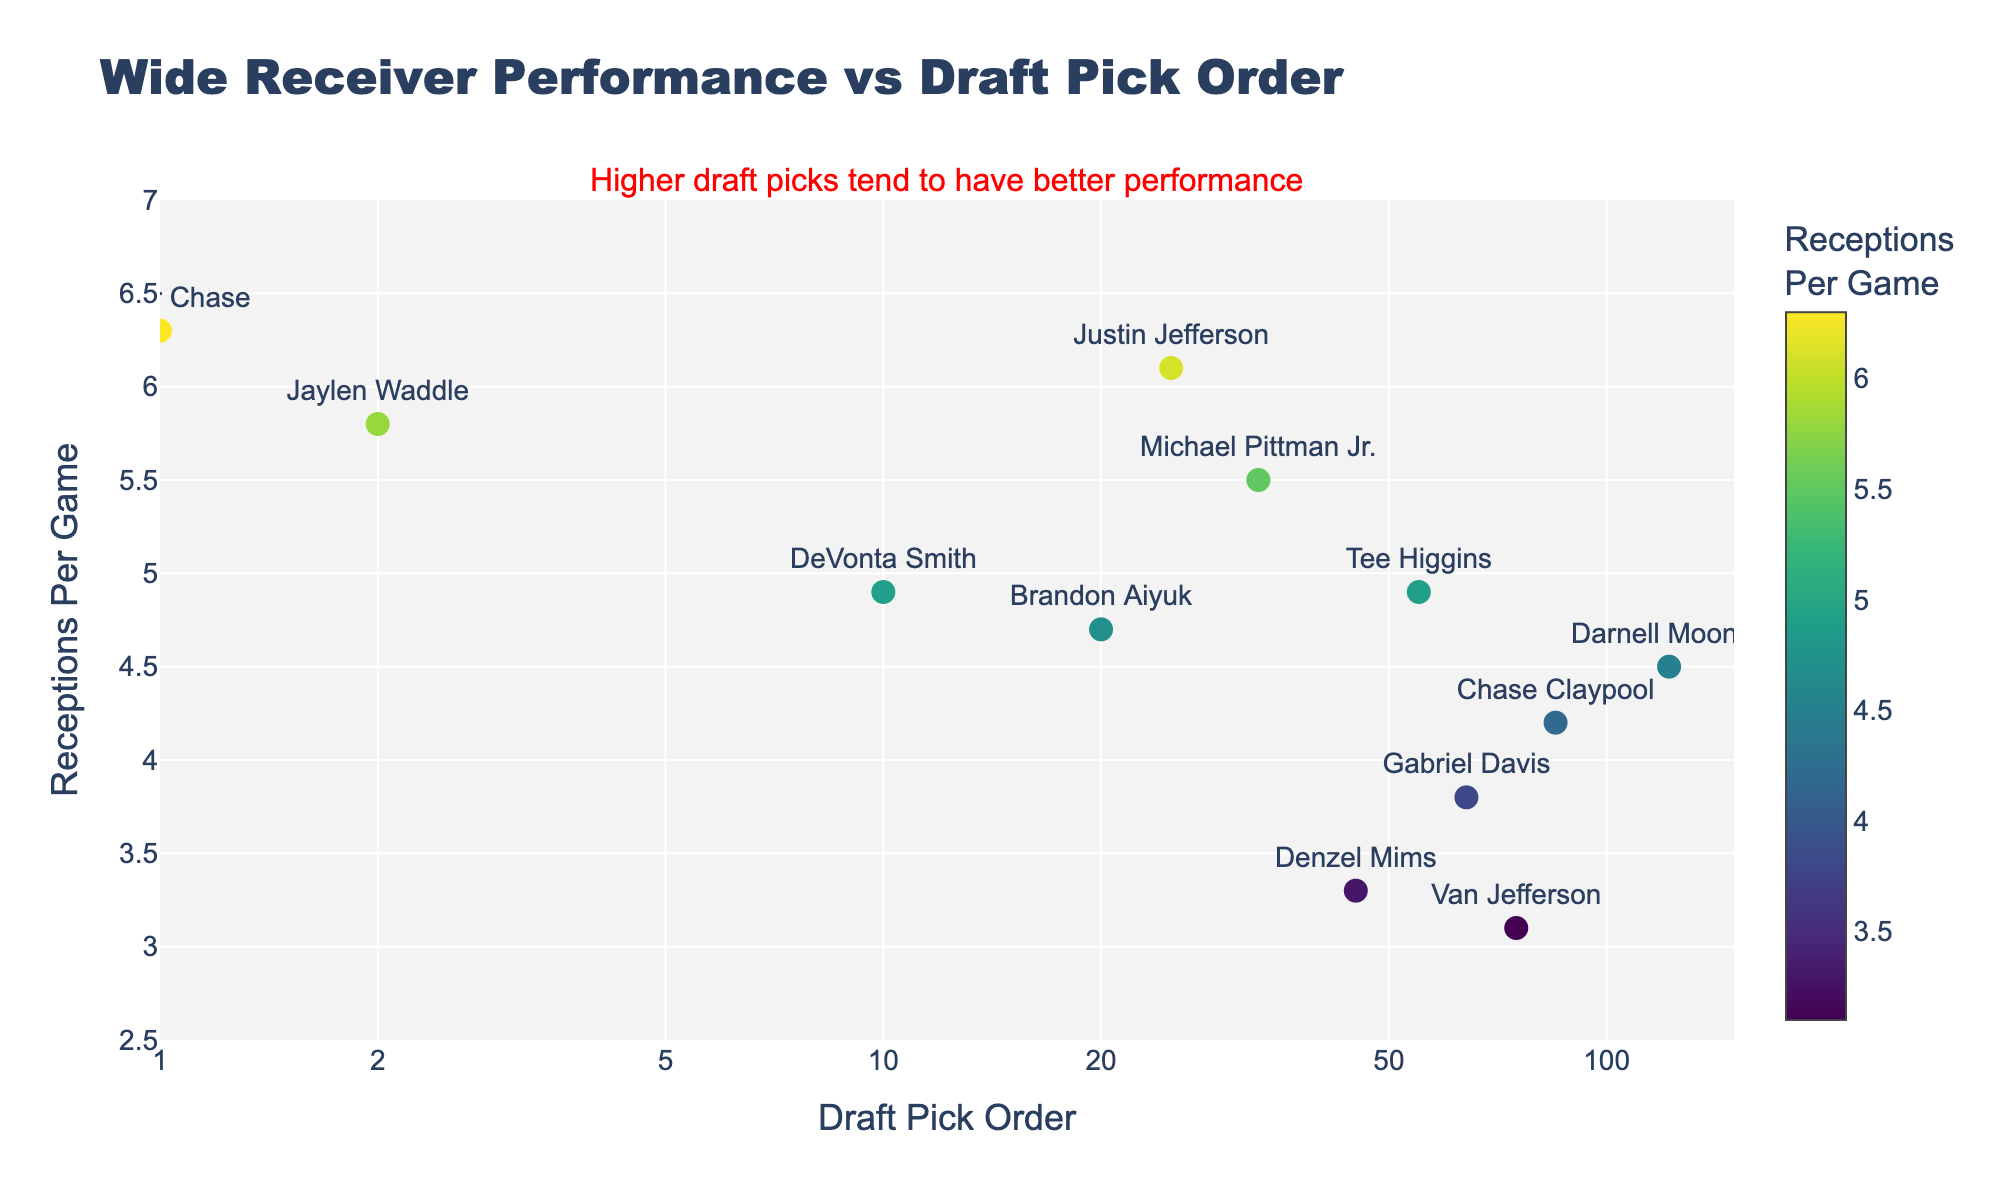What is the title of the figure? The title of the figure is prominently displayed at the top of the chart.
Answer: Wide Receiver Performance vs Draft Pick Order How many players are represented in the plot? Each marker corresponds to a player, and by counting the markers, we can determine the number of players.
Answer: 12 What color scale is used for the markers? The color scale is indicated by the colorbar to the right of the plot, which shows a gradual transition in colors.
Answer: Viridis Which player has the highest number of receptions per game? By examining the y-axis values and hovering over the markers, we can identify the player with the highest y-value.
Answer: Ja'Marr Chase What is the range of the x-axis values? The x-axis starts from the lowest draft pick number to slightly more than 120, shown as a log scale with tick values like 1, 2, 5, 10, 20, 50, 100.
Answer: Approximately 1 to 150 Compare the receptions per game of Justin Jefferson and DeVonta Smith. Who has more receptions per game? By finding the markers for Justin Jefferson and DeVonta Smith, and comparing their y-values, we can determine who has more receptions per game.
Answer: Justin Jefferson What's the median number of receptions per game among the players represented? List the y-values, sort them, and find the middle value: 6.3, 6.1, 5.8, 5.5, 4.9, 4.9, 4.7, 4.5, 4.2, 3.8, 3.3, 3.1. The median is the average of the 6th and 7th values.
Answer: 4.8 Who has the lowest number of receptions per game, and what is the value? By checking the y-axis data and hovering over the markers, identify the player with the lowest y-value and note the value.
Answer: Van Jefferson with 3.1 Do higher draft picks generally have better performance in terms of receptions per game? By examining the chart and the annotation, it indicates a trend where players with lower draft pick numbers (higher picks) tend to cluster at higher y-values, showing better performance.
Answer: Yes Which team has the highest performing wide receiver based on receptions per game? Identify the player(s) with the highest y-value and check their respective teams.
Answer: Cincinnati Bengals (Ja'Marr Chase) 